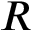Convert formula to latex. <formula><loc_0><loc_0><loc_500><loc_500>R</formula> 